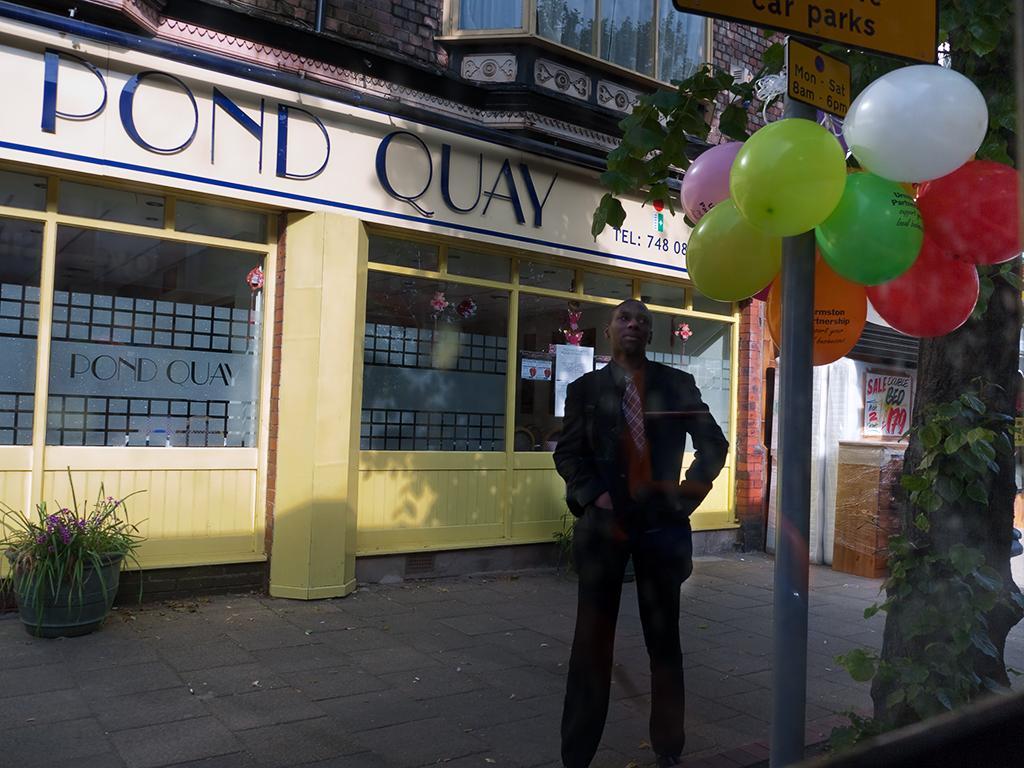Could you give a brief overview of what you see in this image? In this picture there is a sign poles and balloons on the right side of the image and there is a person who is standing on the right side of the image, there is a building in the center of the image, there is a trunk on the right side of the image and there is a plant on the left side of the image. 